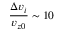Convert formula to latex. <formula><loc_0><loc_0><loc_500><loc_500>\frac { \Delta v _ { i } } { v _ { z 0 } } \sim 1 0 \</formula> 